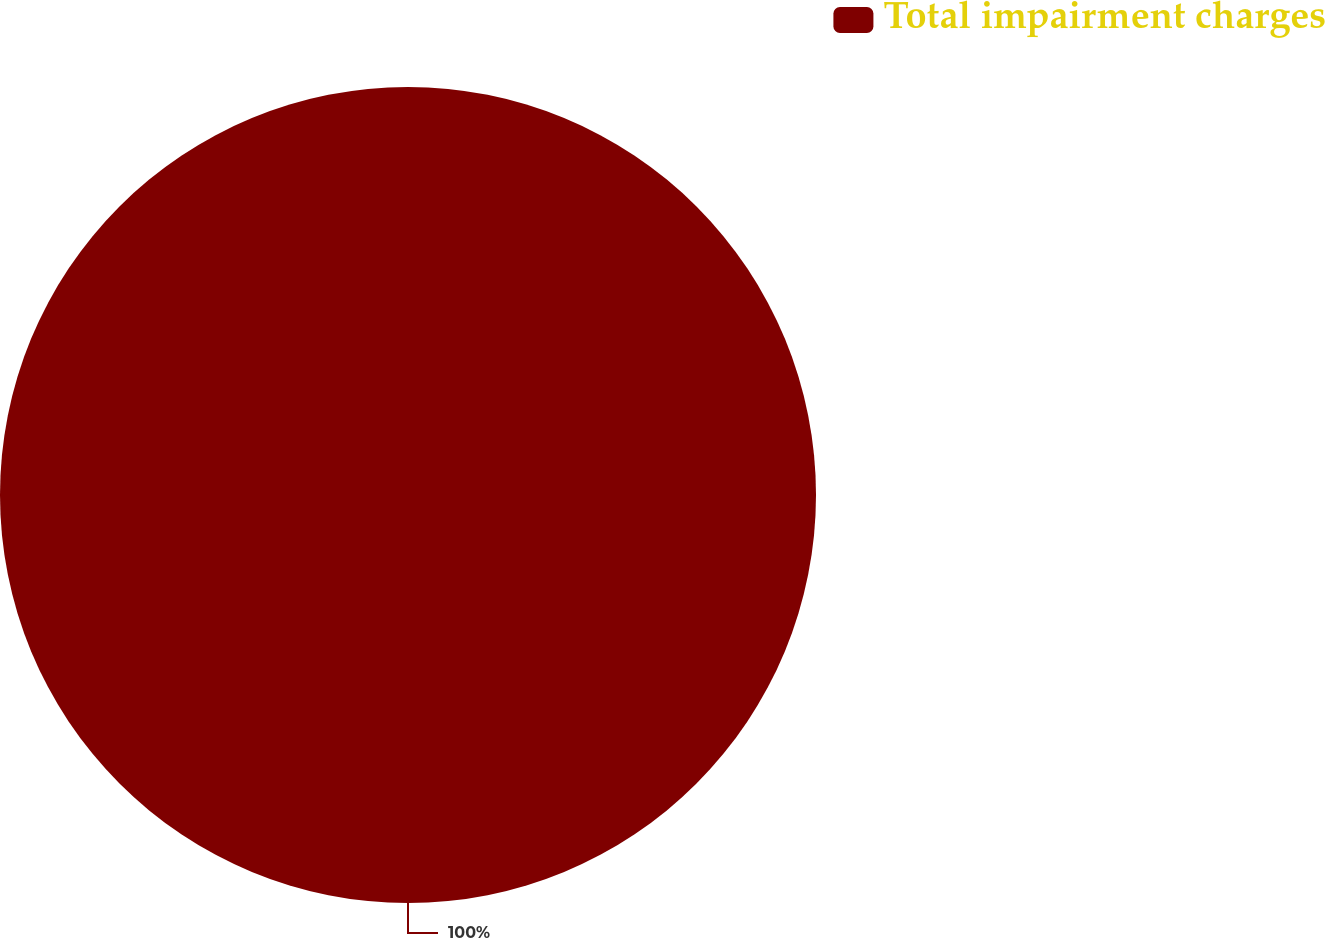Convert chart to OTSL. <chart><loc_0><loc_0><loc_500><loc_500><pie_chart><fcel>Total impairment charges<nl><fcel>100.0%<nl></chart> 